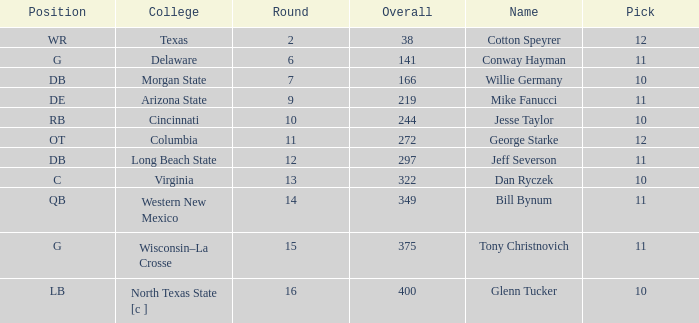What is the lowest round for an overall pick of 349 with a pick number in the round over 11? None. 